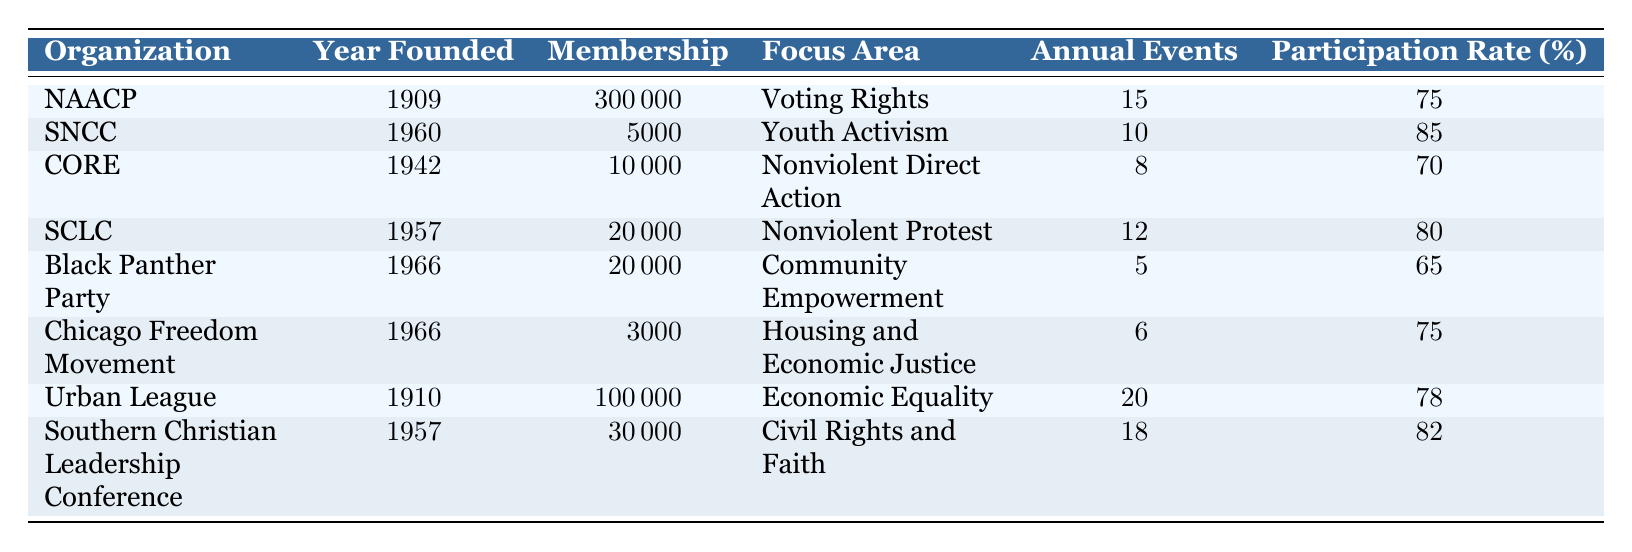What is the membership of the NAACP? The table lists the membership as 300,000 for the NAACP in the corresponding row.
Answer: 300,000 Which organization has the highest participation rate? By scanning the participation rates in the table, SNCC has the highest rate at 85%.
Answer: SNCC How many annual events does the Urban League hold? The table specifies that the Urban League holds 20 annual events in its row.
Answer: 20 What is the focus area of the Black Panther Party? The focus area for the Black Panther Party is listed as Community Empowerment in the table.
Answer: Community Empowerment Which organization has more annual events: CORE or SCLC? CORE has 8 annual events, while SCLC has 12. Since 12 is greater than 8, SCLC has more annual events.
Answer: SCLC What is the difference in participation rates between the Urban League and the Black Panther Party? The Urban League's participation rate is 78%, and the Black Panther Party's is 65%. The difference is 78 - 65 = 13.
Answer: 13 What is the average membership of the organizations founded after 1960? The organizations founded after 1960 are SNCC, the Black Panther Party, and the Chicago Freedom Movement. Their memberships are 5,000, 20,000, and 3,000 respectively. The average is (5,000 + 20,000 + 3,000) / 3 = 28,000 / 3 = 9,333.33, which rounds down to 9,333 when considering whole members.
Answer: 9,333 Is the focus area of the SCLC related to faith? Reviewing the table, the focus area for SCLC is labeled as Civil Rights and Faith, confirming the relationship.
Answer: Yes How many organizations have a participation rate above 75%? The organizations with participation rates above 75% are NAACP (75%), SNCC (85%), SCLC (80%), and Southern Christian Leadership Conference (82%). This totals 4 organizations.
Answer: 4 What organization was founded in 1910? The table shows that both the NAACP and Urban League were founded in 1910, listed directly in the corresponding rows.
Answer: NAACP and Urban League What is the combined membership of all organizations in the table? Summing all memberships: 300,000 (NAACP) + 5,000 (SNCC) + 10,000 (CORE) + 20,000 (SCLC) + 20,000 (Black Panther Party) + 3,000 (Chicago Freedom Movement) + 100,000 (Urban League) + 30,000 (Southern Christian Leadership Conference) totals to 488,000.
Answer: 488,000 